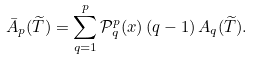Convert formula to latex. <formula><loc_0><loc_0><loc_500><loc_500>\bar { A } _ { p } ( \widetilde { T } ) = \sum _ { q = 1 } ^ { p } \mathcal { P } _ { q } ^ { p } ( x ) \, ( q - 1 ) \, A _ { q } ( \widetilde { T } ) .</formula> 